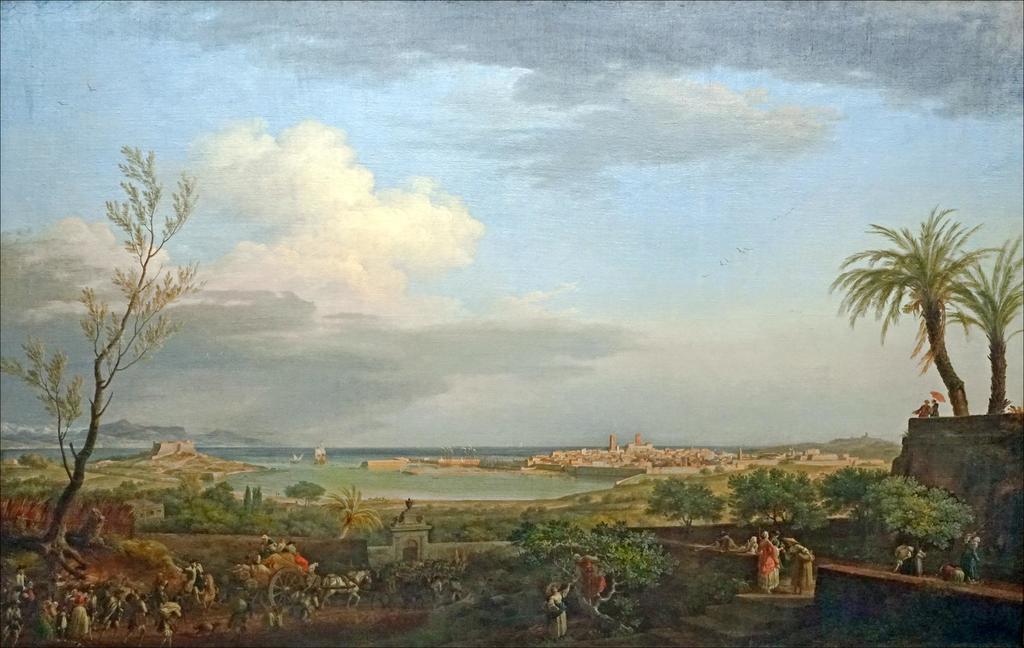Please provide a concise description of this image. I see this is a depiction picture and I see number of people and I see the cart which is tied to this horse and I see number of trees and I see the sky which is a bit cloudy. 